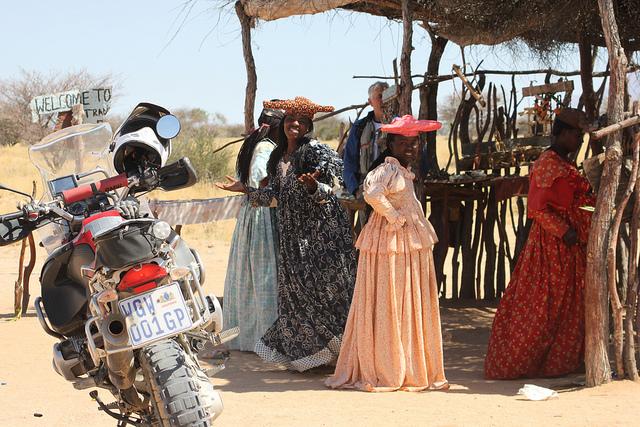How many people are shown?
Write a very short answer. 5. Are the women wearing mini skirts?
Give a very brief answer. No. What are the women wearing on their heads?
Quick response, please. Hats. 